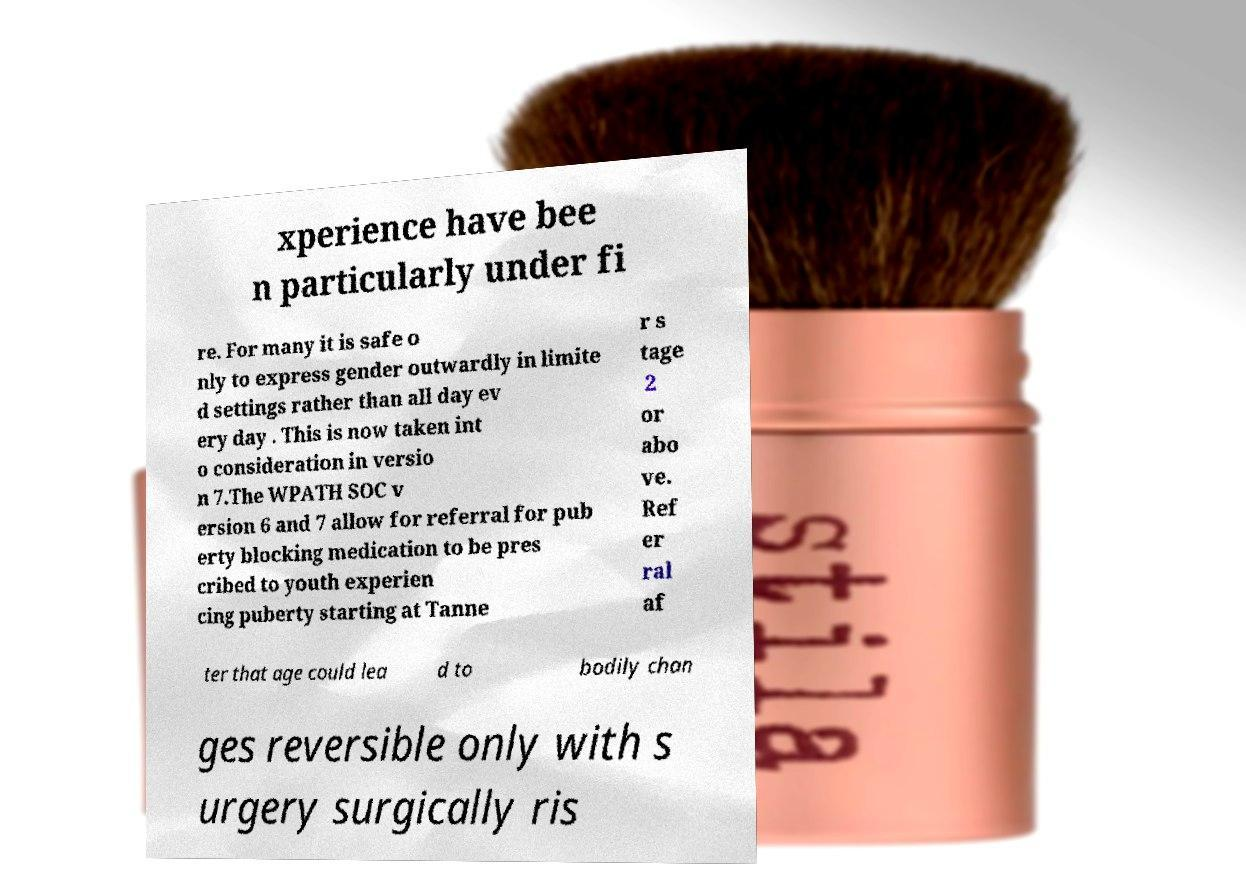What messages or text are displayed in this image? I need them in a readable, typed format. xperience have bee n particularly under fi re. For many it is safe o nly to express gender outwardly in limite d settings rather than all day ev ery day . This is now taken int o consideration in versio n 7.The WPATH SOC v ersion 6 and 7 allow for referral for pub erty blocking medication to be pres cribed to youth experien cing puberty starting at Tanne r s tage 2 or abo ve. Ref er ral af ter that age could lea d to bodily chan ges reversible only with s urgery surgically ris 